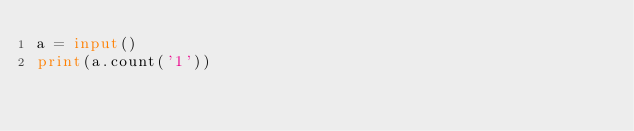<code> <loc_0><loc_0><loc_500><loc_500><_Python_>a = input()
print(a.count('1'))</code> 